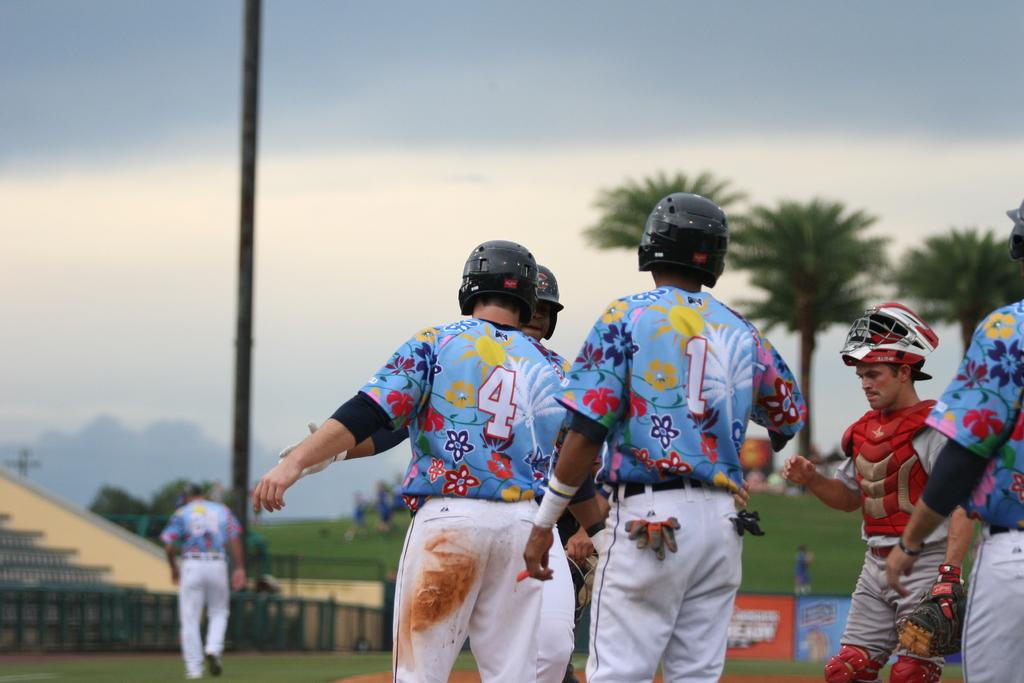What are the people in the image wearing on their heads? The people in the image are wearing helmets. What can be seen in the background of the image? In the background of the image, there are hoardings, trees, people, a pole, a wall, grass, and the sky. Can you describe the environment in the background of the image? The background of the image features a mix of natural elements like trees and grass, as well as man-made structures such as hoardings, a pole, and a wall. The sky is also visible. What type of sleet can be seen falling from the sky in the image? There is no sleet present in the image; the sky is visible but no precipitation is shown. Can you tell me which parent is accompanying the children in the image? There are no children or parents mentioned or depicted in the image. 